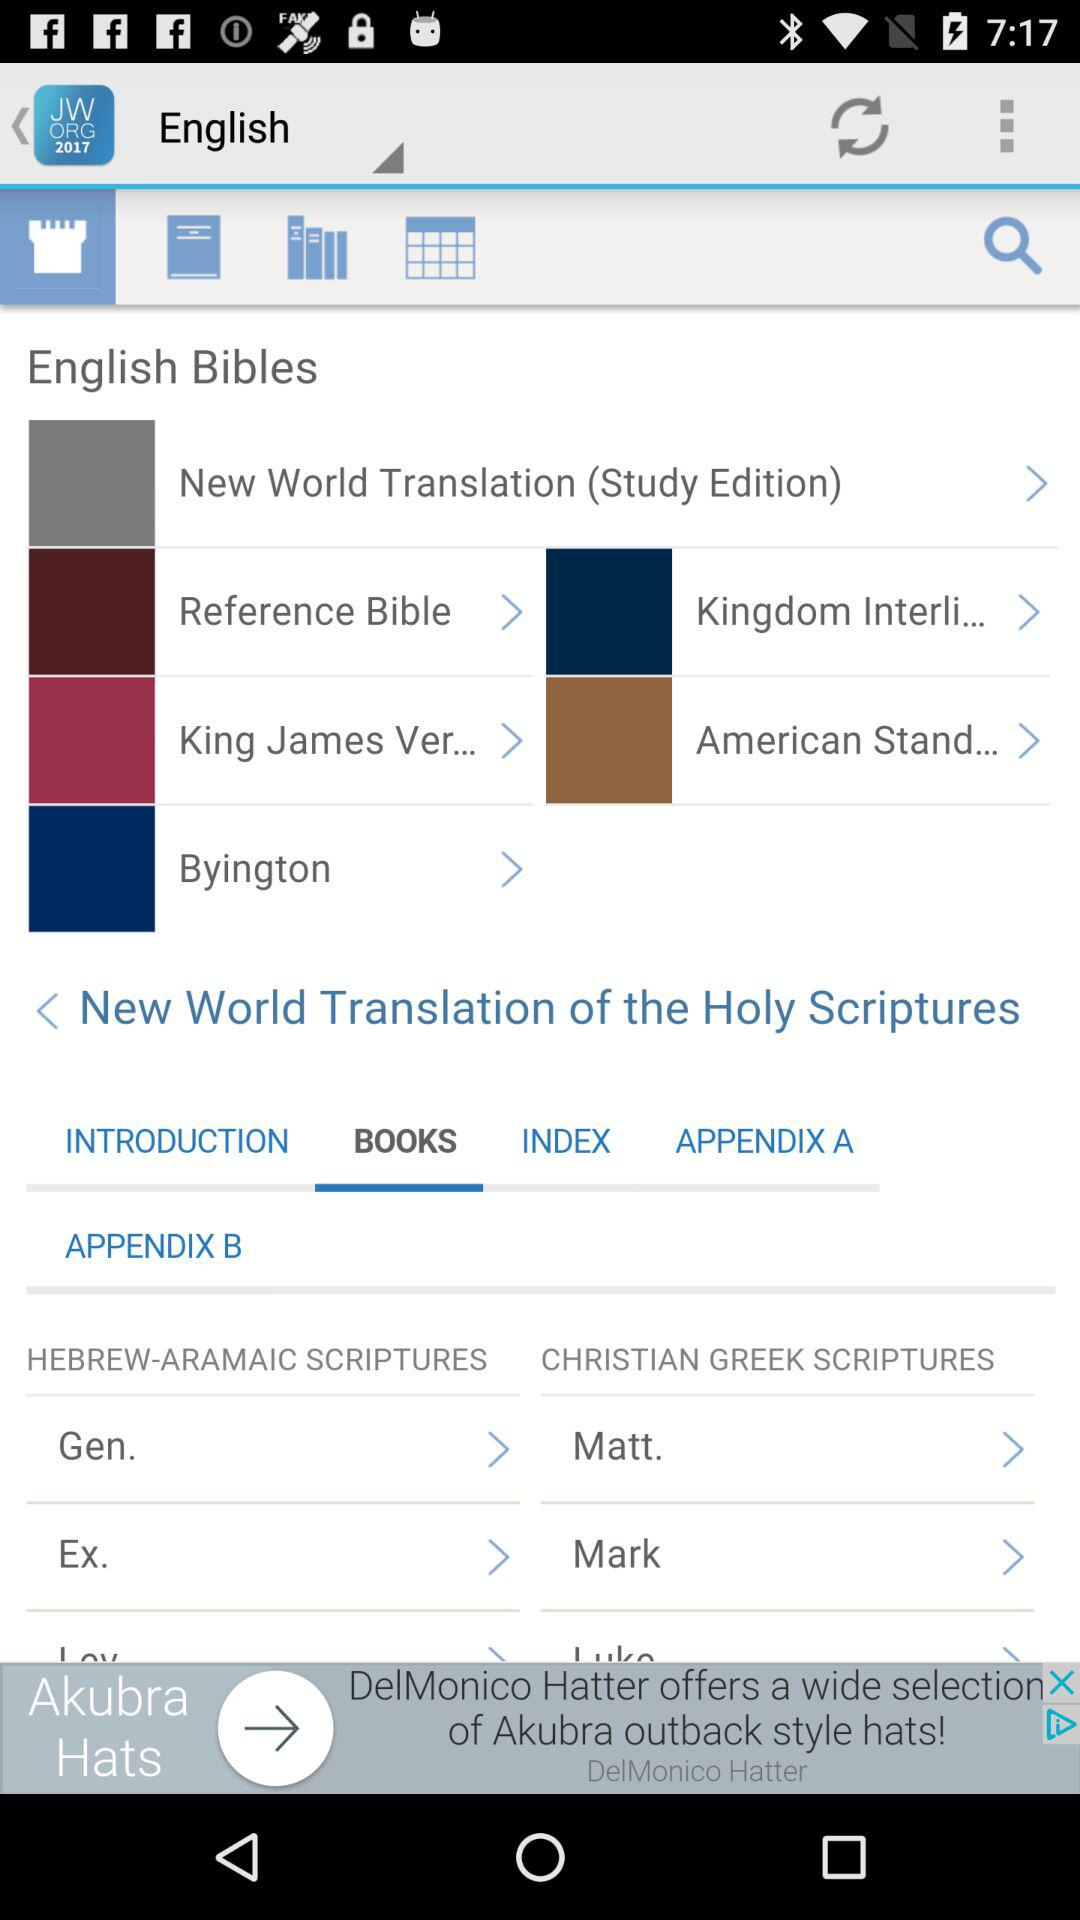Which tab is selected? The selected tab is "Books". 